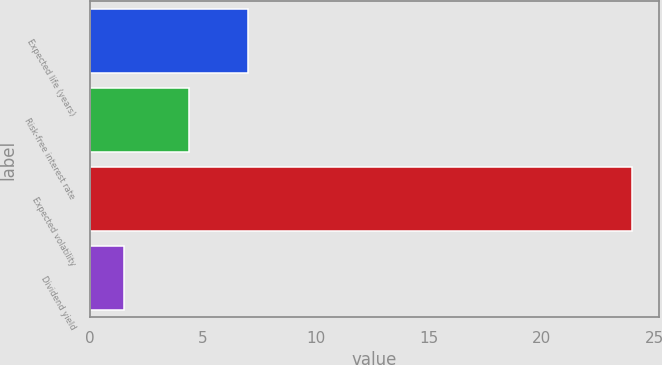Convert chart. <chart><loc_0><loc_0><loc_500><loc_500><bar_chart><fcel>Expected life (years)<fcel>Risk-free interest rate<fcel>Expected volatility<fcel>Dividend yield<nl><fcel>7<fcel>4.4<fcel>24<fcel>1.5<nl></chart> 